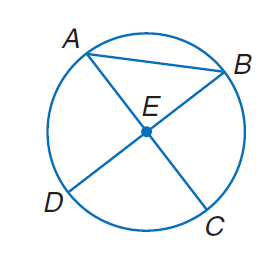Answer the mathemtical geometry problem and directly provide the correct option letter.
Question: Suppose C E = 5.2 inches. Find the diameter of the circle.
Choices: A: 2.6 B: 4.8 C: 10.4 D: 20.8 C 